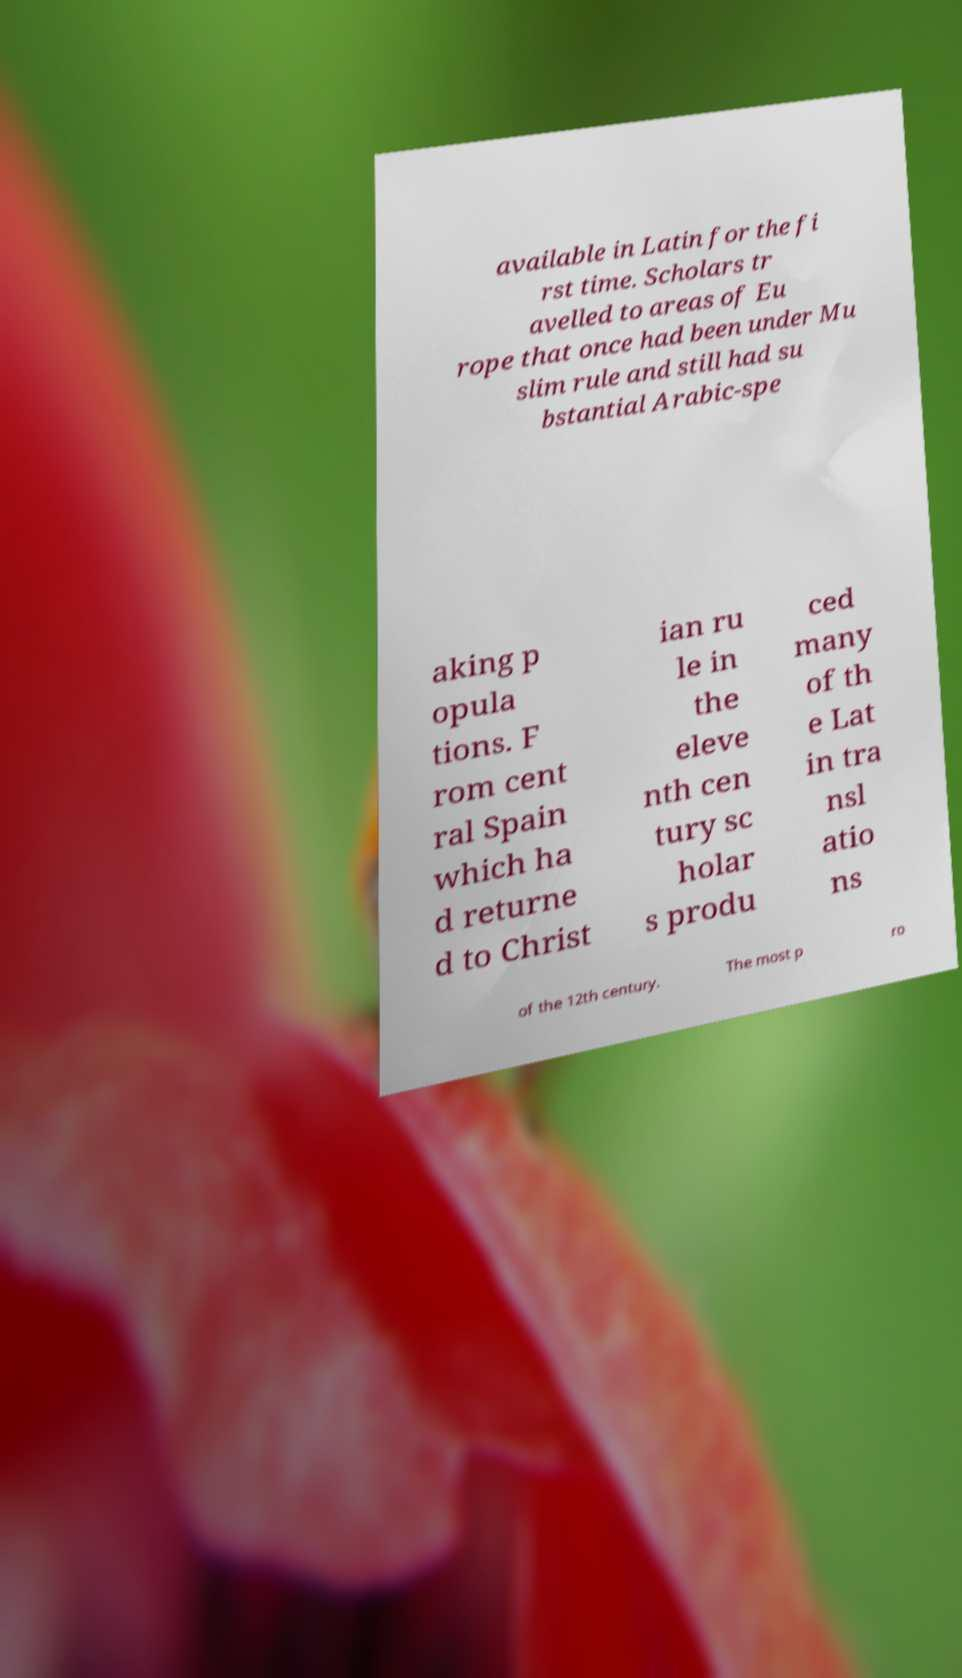Could you extract and type out the text from this image? available in Latin for the fi rst time. Scholars tr avelled to areas of Eu rope that once had been under Mu slim rule and still had su bstantial Arabic-spe aking p opula tions. F rom cent ral Spain which ha d returne d to Christ ian ru le in the eleve nth cen tury sc holar s produ ced many of th e Lat in tra nsl atio ns of the 12th century. The most p ro 